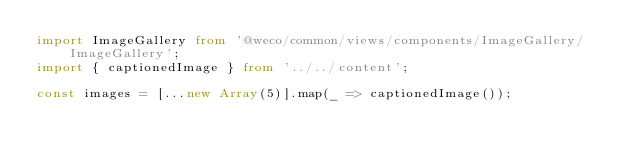Convert code to text. <code><loc_0><loc_0><loc_500><loc_500><_TypeScript_>import ImageGallery from '@weco/common/views/components/ImageGallery/ImageGallery';
import { captionedImage } from '../../content';

const images = [...new Array(5)].map(_ => captionedImage());
</code> 